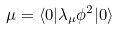Convert formula to latex. <formula><loc_0><loc_0><loc_500><loc_500>\mu = \langle 0 | \lambda _ { \mu } \phi ^ { 2 } | 0 \rangle</formula> 